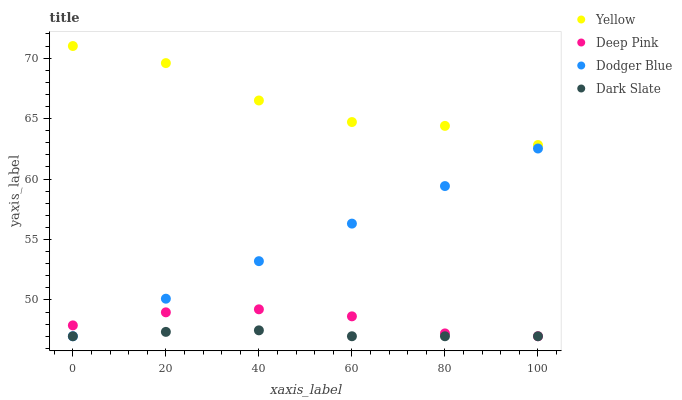Does Dark Slate have the minimum area under the curve?
Answer yes or no. Yes. Does Yellow have the maximum area under the curve?
Answer yes or no. Yes. Does Deep Pink have the minimum area under the curve?
Answer yes or no. No. Does Deep Pink have the maximum area under the curve?
Answer yes or no. No. Is Dodger Blue the smoothest?
Answer yes or no. Yes. Is Yellow the roughest?
Answer yes or no. Yes. Is Deep Pink the smoothest?
Answer yes or no. No. Is Deep Pink the roughest?
Answer yes or no. No. Does Dark Slate have the lowest value?
Answer yes or no. Yes. Does Yellow have the lowest value?
Answer yes or no. No. Does Yellow have the highest value?
Answer yes or no. Yes. Does Deep Pink have the highest value?
Answer yes or no. No. Is Deep Pink less than Yellow?
Answer yes or no. Yes. Is Yellow greater than Dodger Blue?
Answer yes or no. Yes. Does Deep Pink intersect Dark Slate?
Answer yes or no. Yes. Is Deep Pink less than Dark Slate?
Answer yes or no. No. Is Deep Pink greater than Dark Slate?
Answer yes or no. No. Does Deep Pink intersect Yellow?
Answer yes or no. No. 